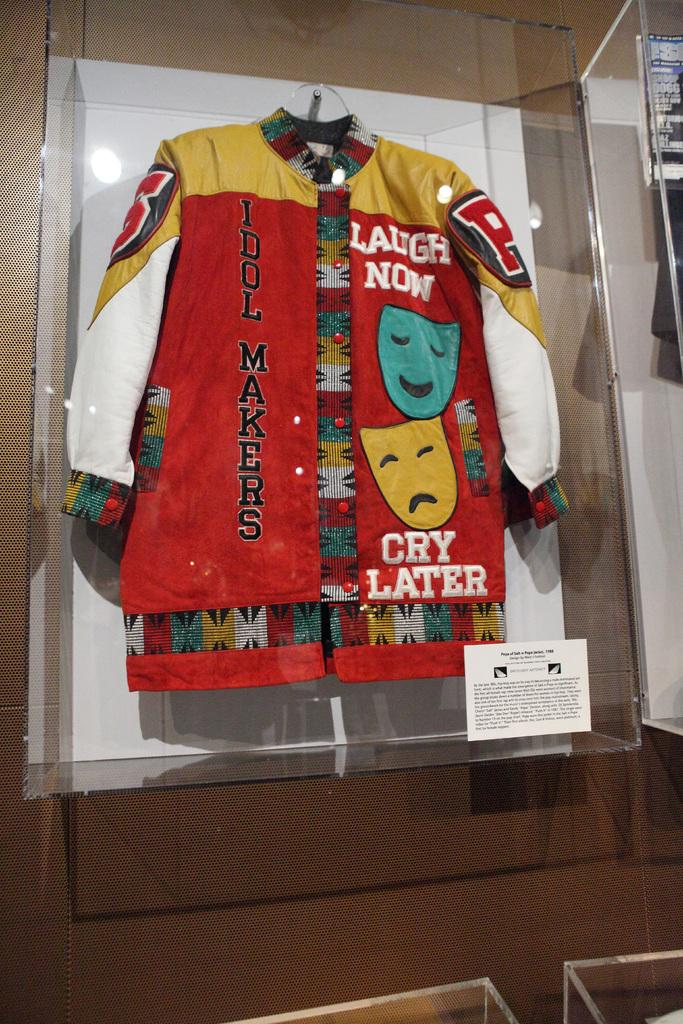<image>
Relay a brief, clear account of the picture shown. A red and gold letterman style jacket featuring a smiling and frowing face and the words "laugh now cry later." 